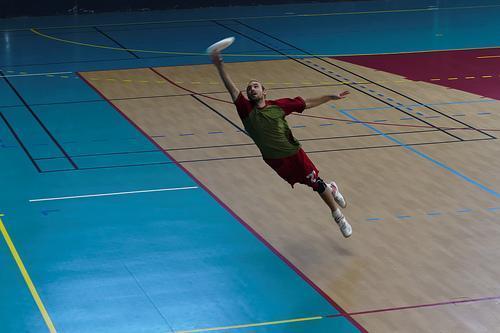How many people are in the photo?
Give a very brief answer. 1. 